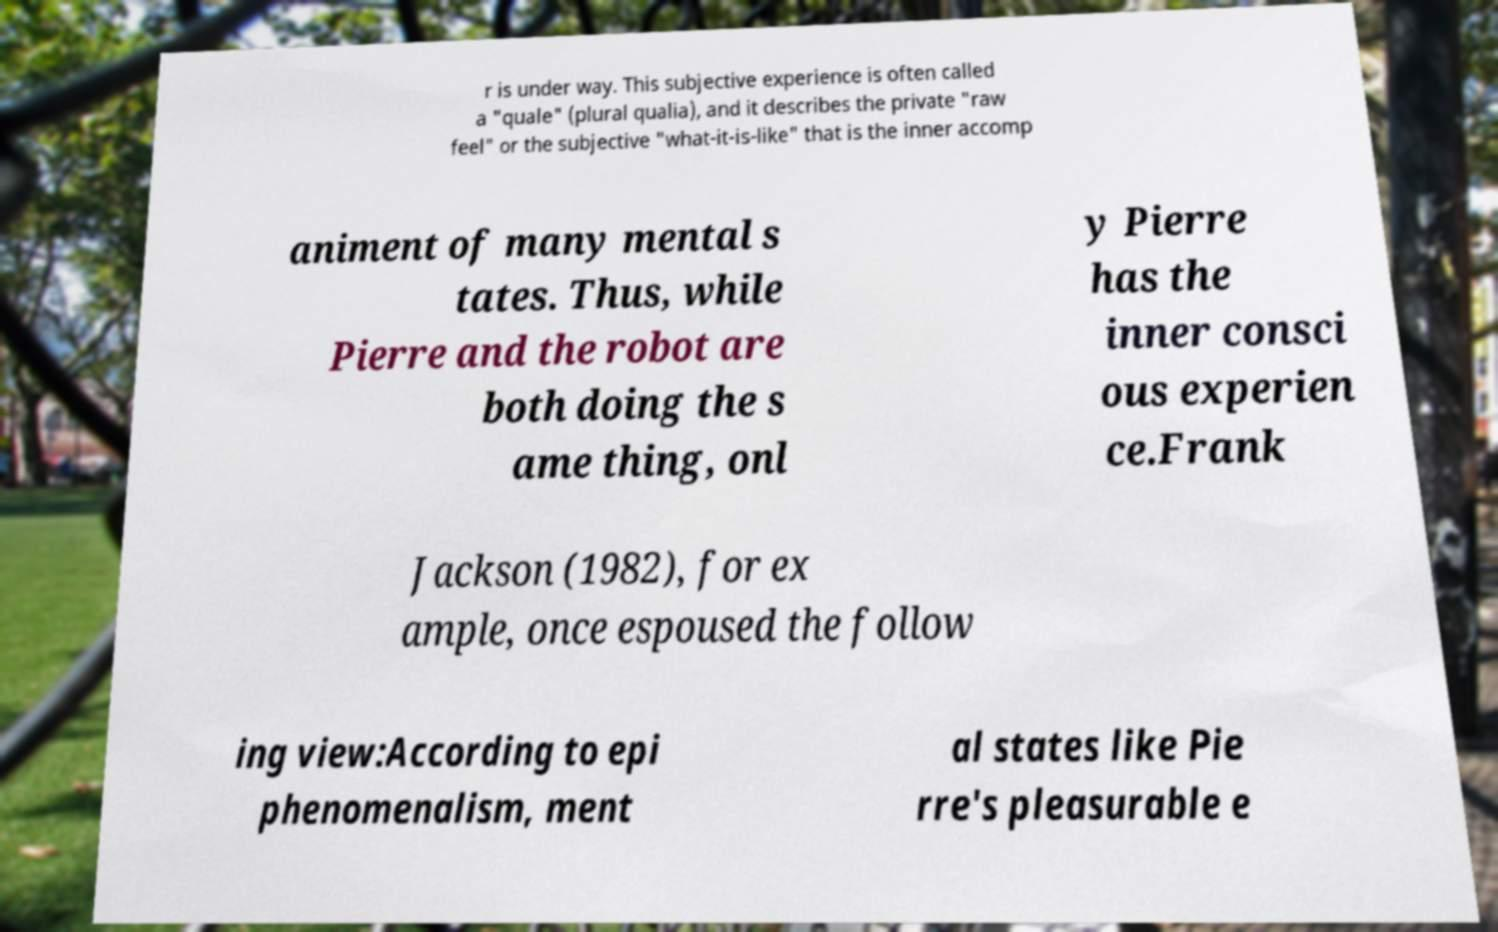For documentation purposes, I need the text within this image transcribed. Could you provide that? r is under way. This subjective experience is often called a "quale" (plural qualia), and it describes the private "raw feel" or the subjective "what-it-is-like" that is the inner accomp animent of many mental s tates. Thus, while Pierre and the robot are both doing the s ame thing, onl y Pierre has the inner consci ous experien ce.Frank Jackson (1982), for ex ample, once espoused the follow ing view:According to epi phenomenalism, ment al states like Pie rre's pleasurable e 